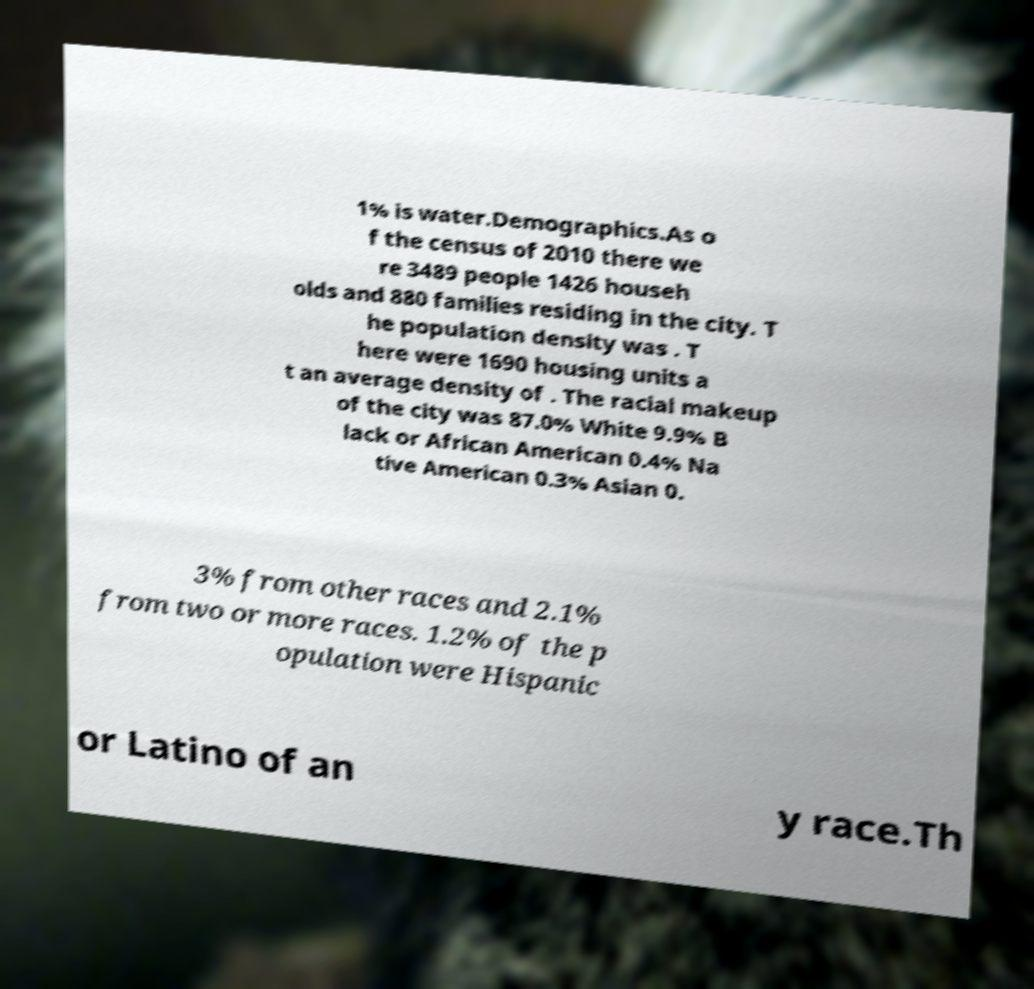I need the written content from this picture converted into text. Can you do that? 1% is water.Demographics.As o f the census of 2010 there we re 3489 people 1426 househ olds and 880 families residing in the city. T he population density was . T here were 1690 housing units a t an average density of . The racial makeup of the city was 87.0% White 9.9% B lack or African American 0.4% Na tive American 0.3% Asian 0. 3% from other races and 2.1% from two or more races. 1.2% of the p opulation were Hispanic or Latino of an y race.Th 